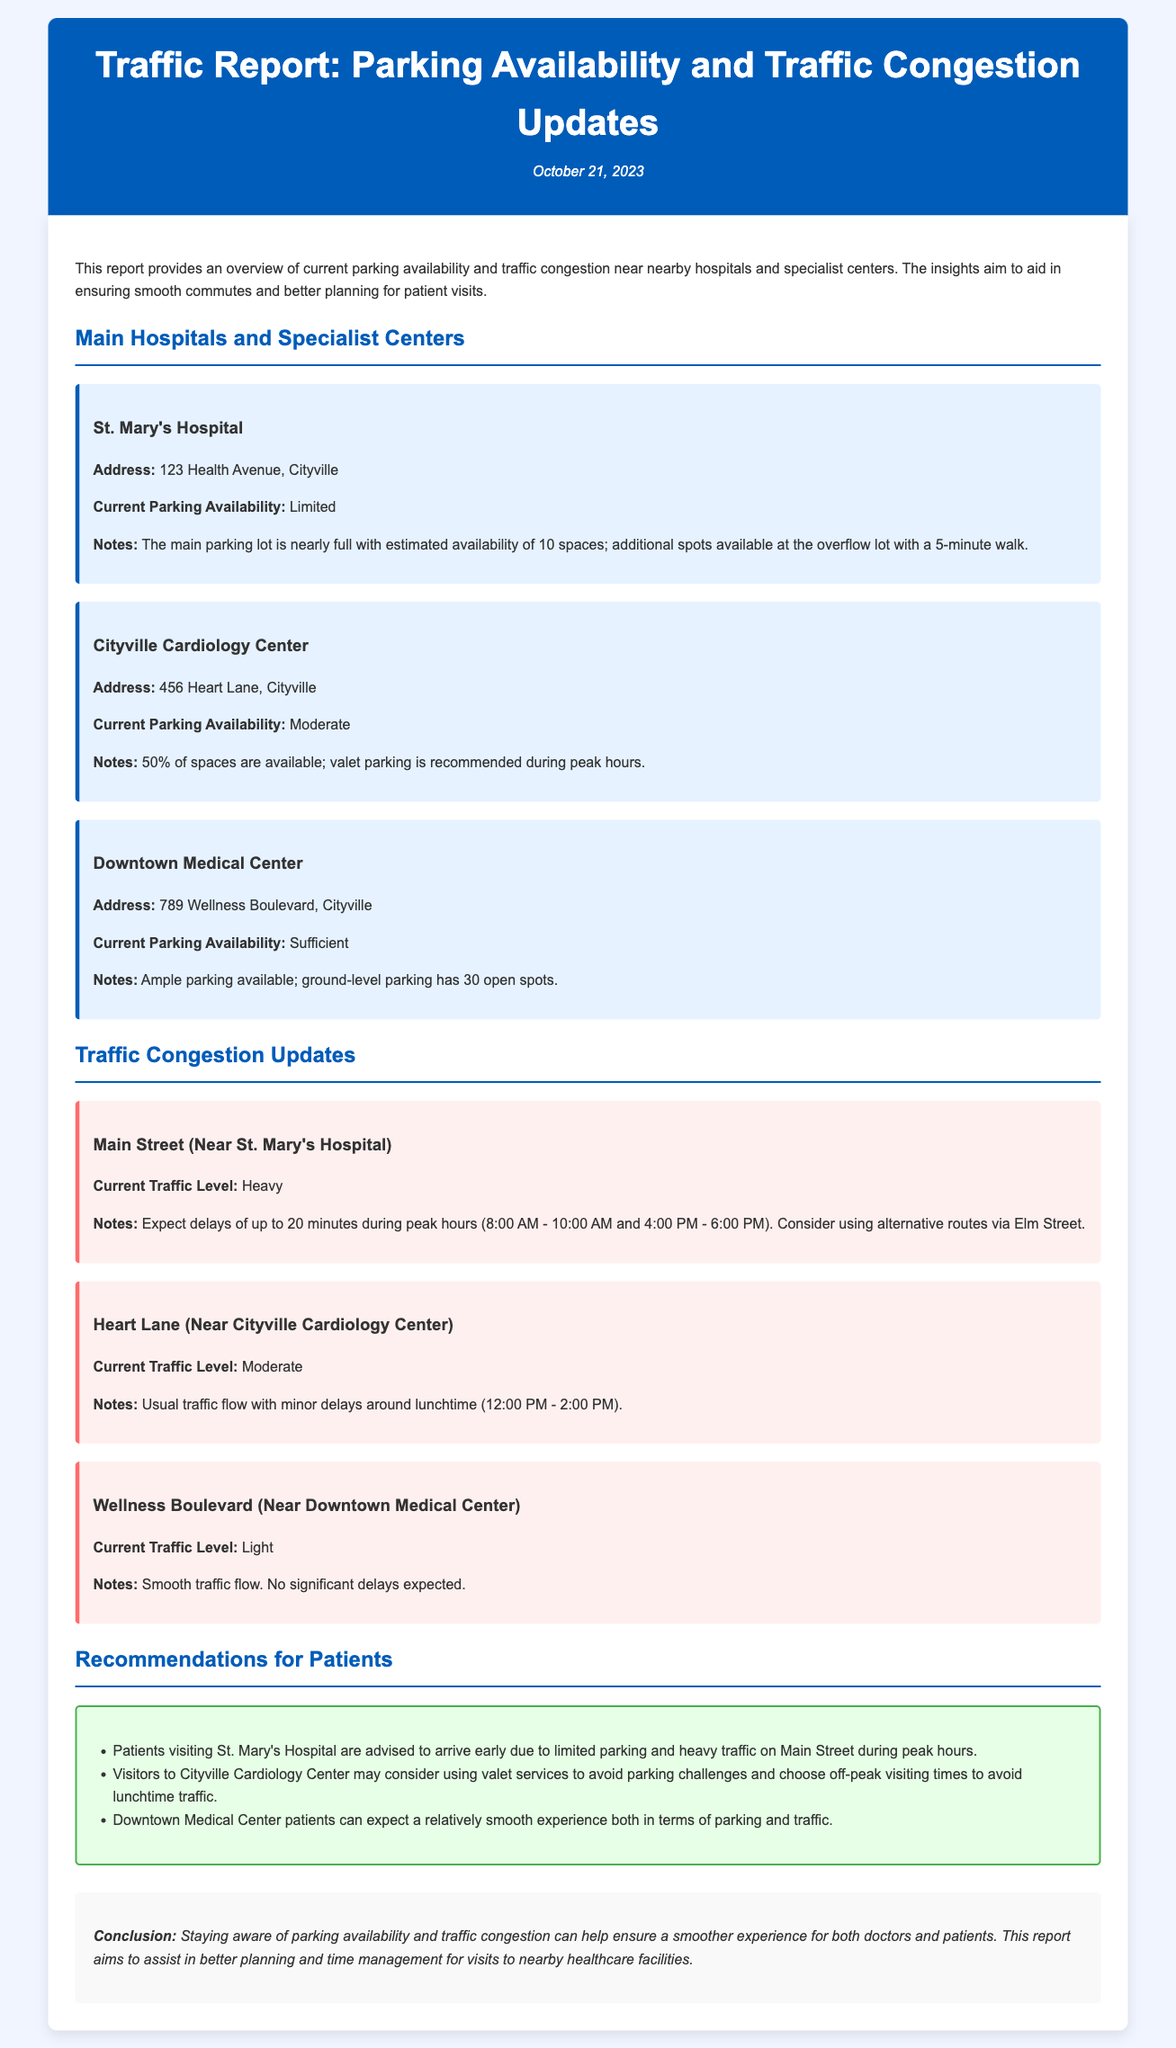What is the address of St. Mary's Hospital? The address is stated in the hospital card section where it mentions the location of St. Mary's Hospital.
Answer: 123 Health Avenue, Cityville What is the current parking availability at Cityville Cardiology Center? This information is provided in the hospital card for Cityville Cardiology Center, indicating the parking status.
Answer: Moderate How many open spots are available at Downtown Medical Center? The number of open spots is given in the Downtown Medical Center's parking notes.
Answer: 30 What is the estimated delay on Main Street during peak hours? The traffic update specifies the expected delay for Main Street during peak traffic periods.
Answer: 20 minutes What are the recommended visiting times for Cityville Cardiology Center? Recommendations include avoiding lunchtime traffic, which is detailed in the patient recommendations section.
Answer: Off-peak visiting times What is the current traffic level on Wellness Boulevard? The current traffic state is stated in the traffic update for Wellness Boulevard.
Answer: Light What parking service is recommended for patients visiting Cityville Cardiology Center? The recommendation regarding a specific parking service is mentioned in the guidelines for visiting the center.
Answer: Valet parking What is the main reason for arriving early at St. Mary's Hospital? The document explains the reason for arriving early in the patient recommendations for St. Mary's Hospital.
Answer: Limited parking What traffic condition is reported on Heart Lane during lunchtime? The median traffic condition during lunchtime is specified in the update for Heart Lane.
Answer: Minor delays 